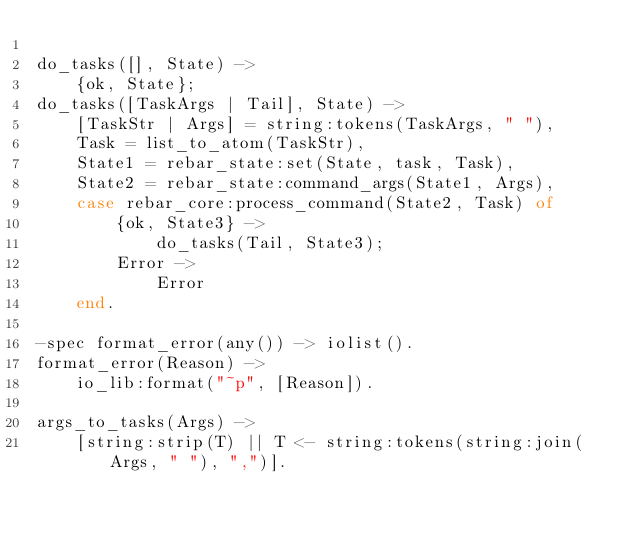<code> <loc_0><loc_0><loc_500><loc_500><_Erlang_>
do_tasks([], State) ->
    {ok, State};
do_tasks([TaskArgs | Tail], State) ->
    [TaskStr | Args] = string:tokens(TaskArgs, " "),
    Task = list_to_atom(TaskStr),
    State1 = rebar_state:set(State, task, Task),
    State2 = rebar_state:command_args(State1, Args),
    case rebar_core:process_command(State2, Task) of
        {ok, State3} ->
            do_tasks(Tail, State3);
        Error ->
            Error
    end.

-spec format_error(any()) -> iolist().
format_error(Reason) ->
    io_lib:format("~p", [Reason]).

args_to_tasks(Args) ->
    [string:strip(T) || T <- string:tokens(string:join(Args, " "), ",")].
</code> 